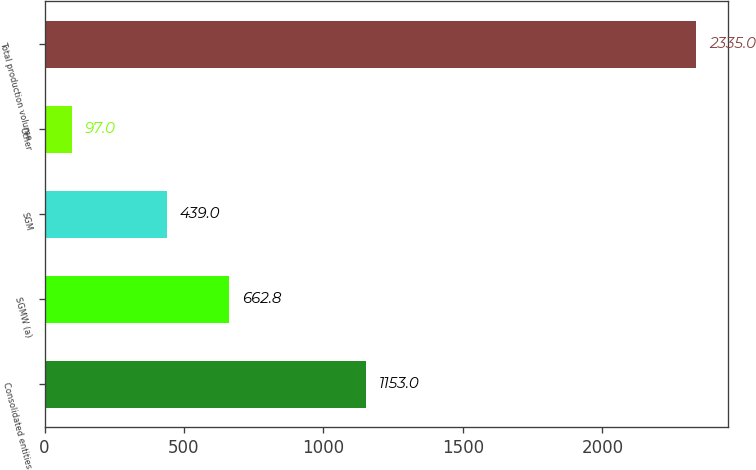Convert chart. <chart><loc_0><loc_0><loc_500><loc_500><bar_chart><fcel>Consolidated entities<fcel>SGMW (a)<fcel>SGM<fcel>Other<fcel>Total production volume<nl><fcel>1153<fcel>662.8<fcel>439<fcel>97<fcel>2335<nl></chart> 